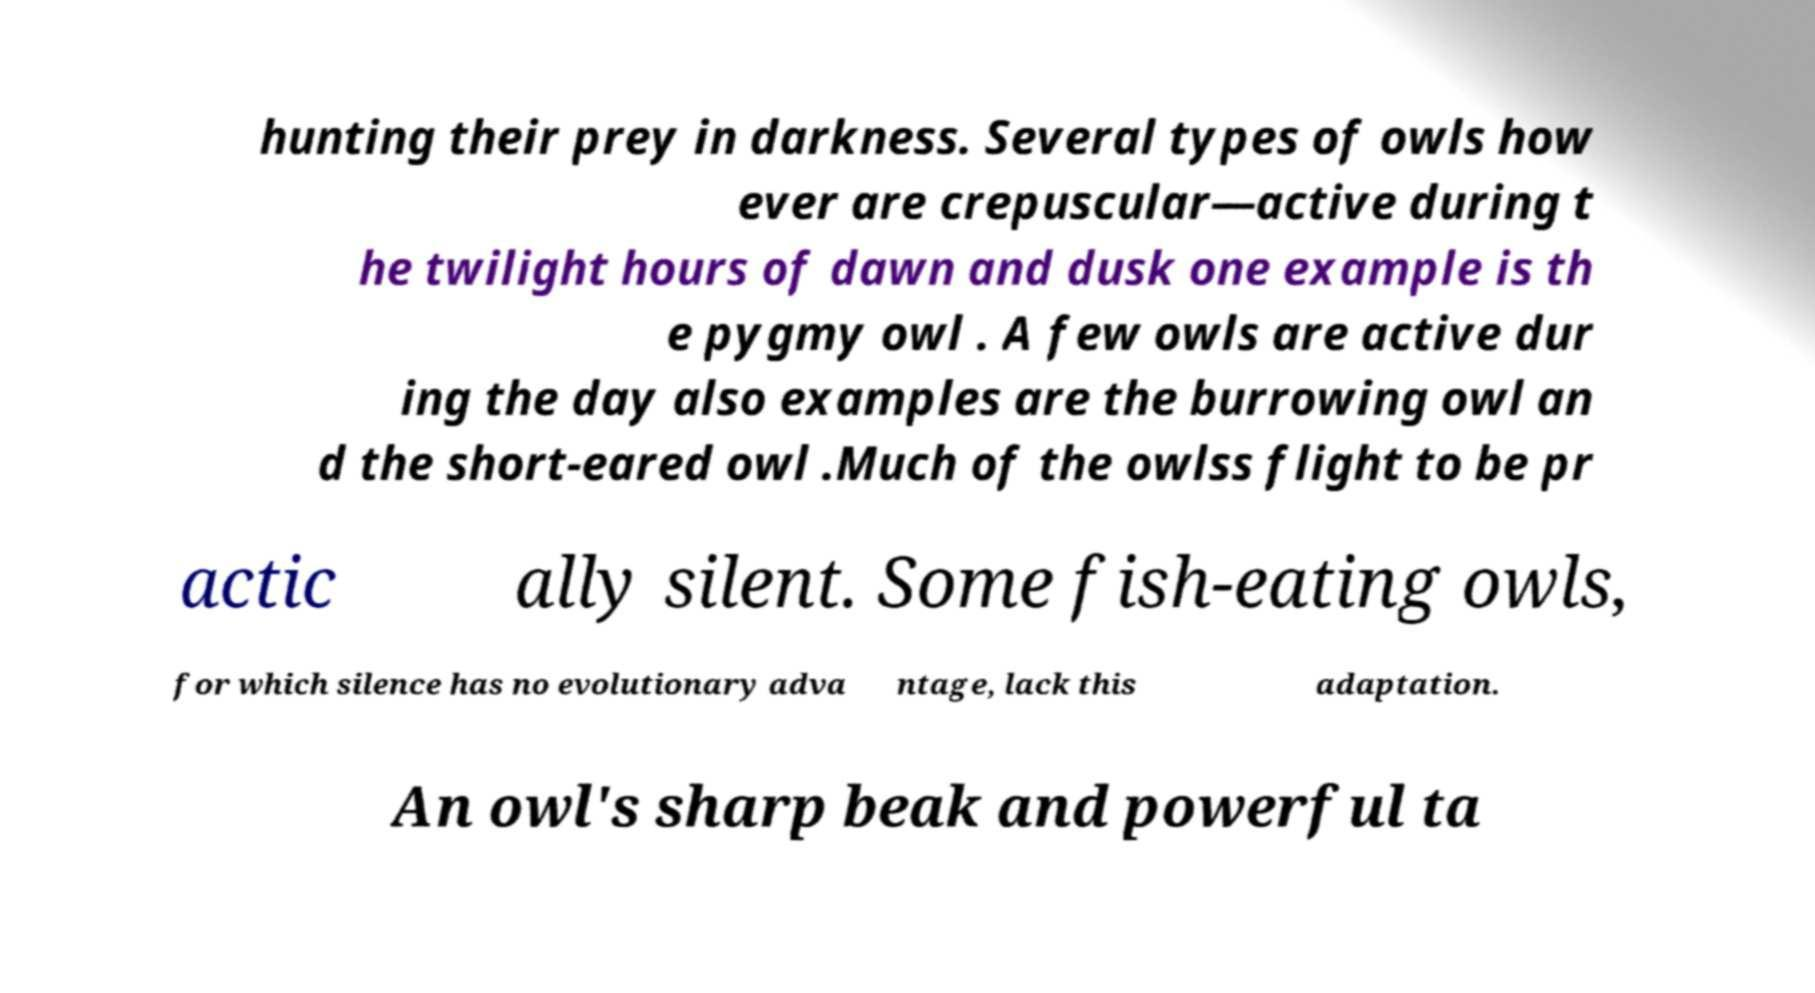For documentation purposes, I need the text within this image transcribed. Could you provide that? hunting their prey in darkness. Several types of owls how ever are crepuscular—active during t he twilight hours of dawn and dusk one example is th e pygmy owl . A few owls are active dur ing the day also examples are the burrowing owl an d the short-eared owl .Much of the owlss flight to be pr actic ally silent. Some fish-eating owls, for which silence has no evolutionary adva ntage, lack this adaptation. An owl's sharp beak and powerful ta 